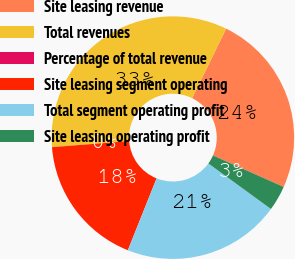<chart> <loc_0><loc_0><loc_500><loc_500><pie_chart><fcel>Site leasing revenue<fcel>Total revenues<fcel>Percentage of total revenue<fcel>Site leasing segment operating<fcel>Total segment operating profit<fcel>Site leasing operating profit<nl><fcel>24.43%<fcel>33.48%<fcel>0.01%<fcel>17.69%<fcel>21.04%<fcel>3.35%<nl></chart> 